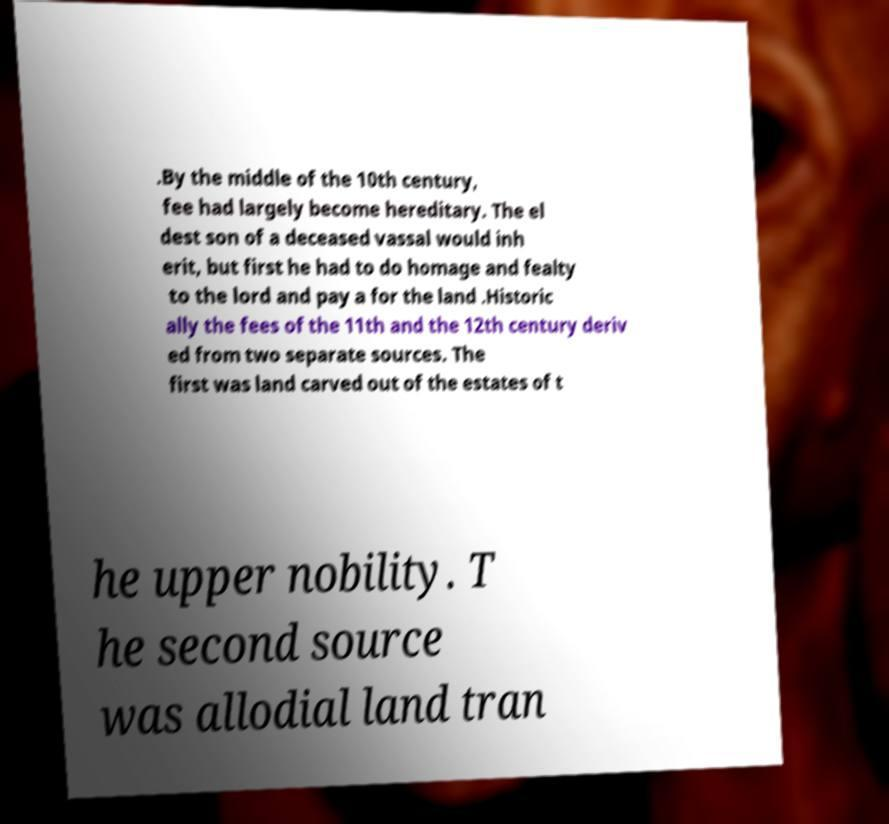I need the written content from this picture converted into text. Can you do that? .By the middle of the 10th century, fee had largely become hereditary. The el dest son of a deceased vassal would inh erit, but first he had to do homage and fealty to the lord and pay a for the land .Historic ally the fees of the 11th and the 12th century deriv ed from two separate sources. The first was land carved out of the estates of t he upper nobility. T he second source was allodial land tran 